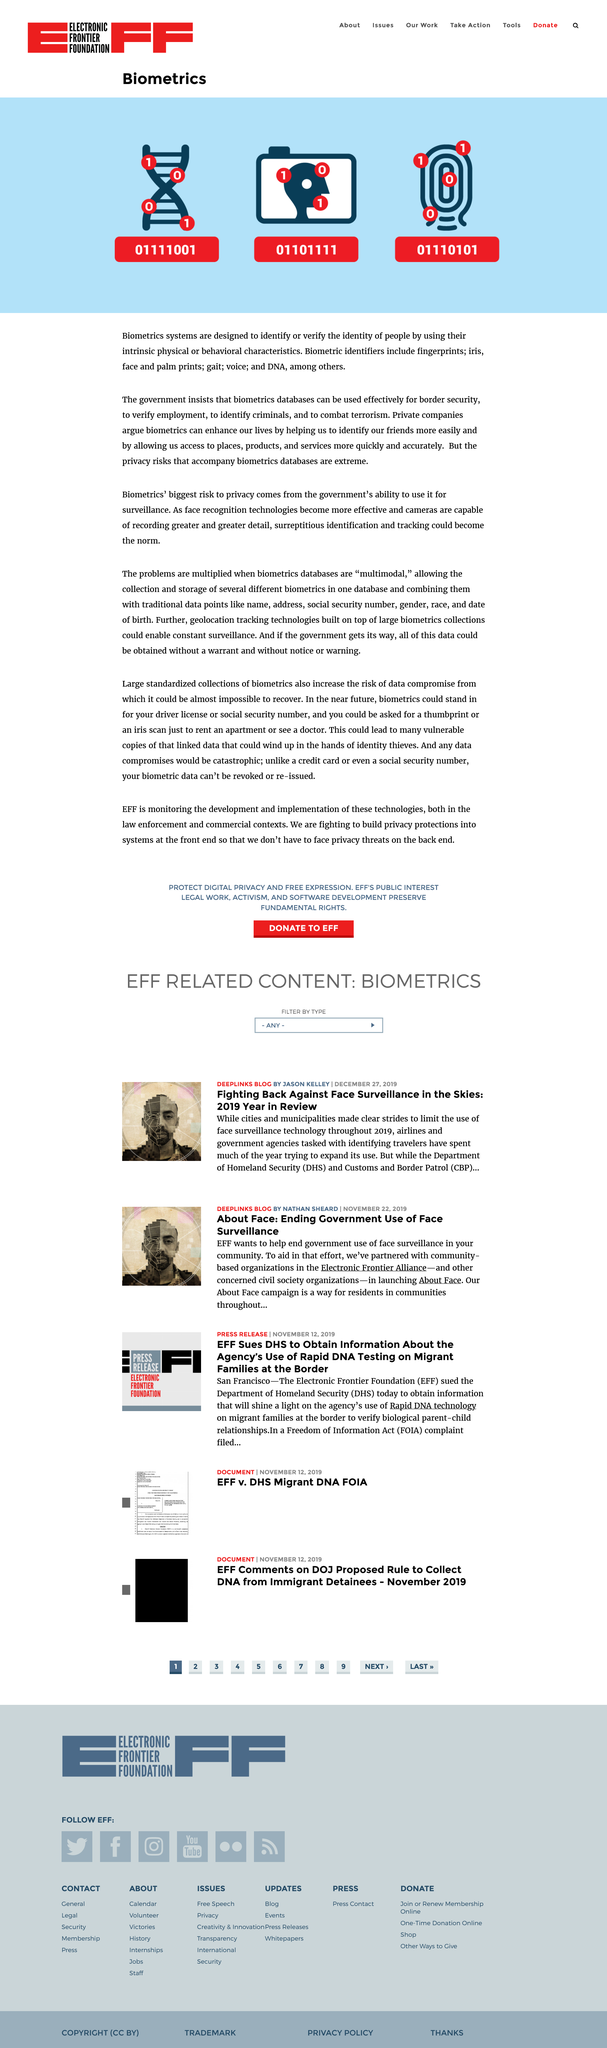Point out several critical features in this image. Biometric identifiers are a set of unique physical characteristics that can be used to identify an individual, such as fingerprints, iris, face and palm prints, gait, voice, and DNA. Biometrics poses a significant risk to privacy due to the government's ability to use it for surveillance purposes. 